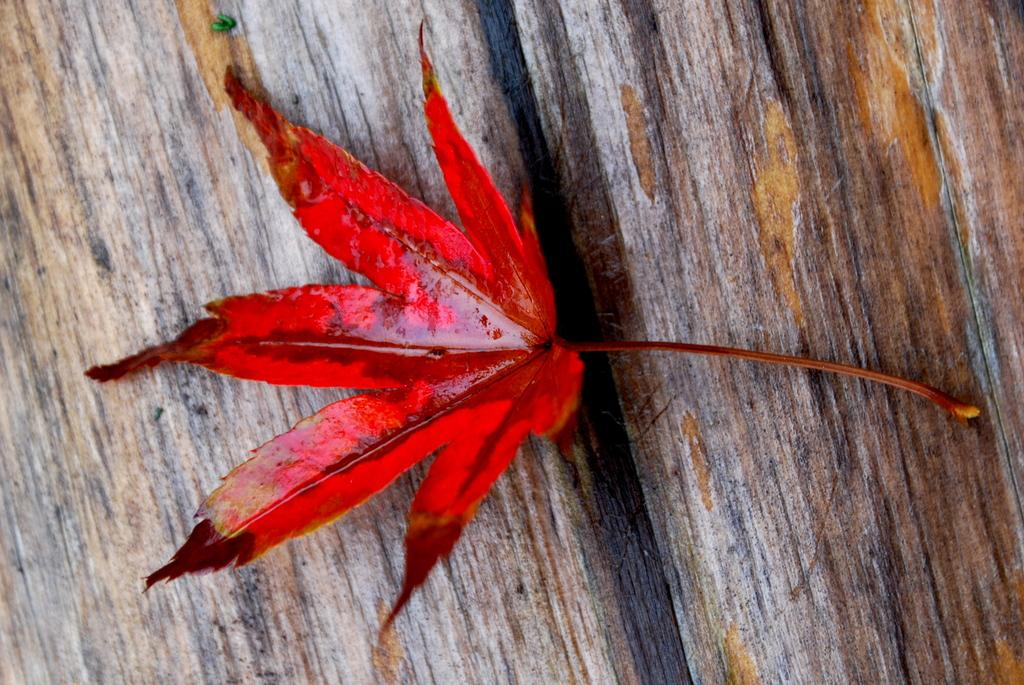What color is the leaf in the image? The leaf in the image is red. What type of surface is the leaf placed on? The leaf is placed on a wooden surface. What type of dirt can be seen on the nation in the image? There is no dirt or nation present in the image; it only features a red leaf on a wooden surface. 